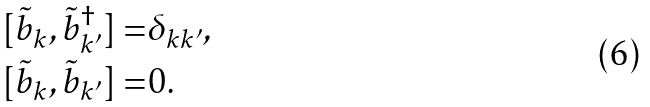Convert formula to latex. <formula><loc_0><loc_0><loc_500><loc_500>[ \tilde { b } _ { k } , \tilde { b } _ { k ^ { \prime } } ^ { \dagger } ] = & \delta _ { k k ^ { \prime } } , \\ [ \tilde { b } _ { k } , \tilde { b } _ { k ^ { \prime } } ] = & 0 .</formula> 